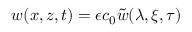Convert formula to latex. <formula><loc_0><loc_0><loc_500><loc_500>w ( x , z , t ) = \epsilon c _ { 0 } \tilde { w } ( \lambda , \xi , \tau )</formula> 